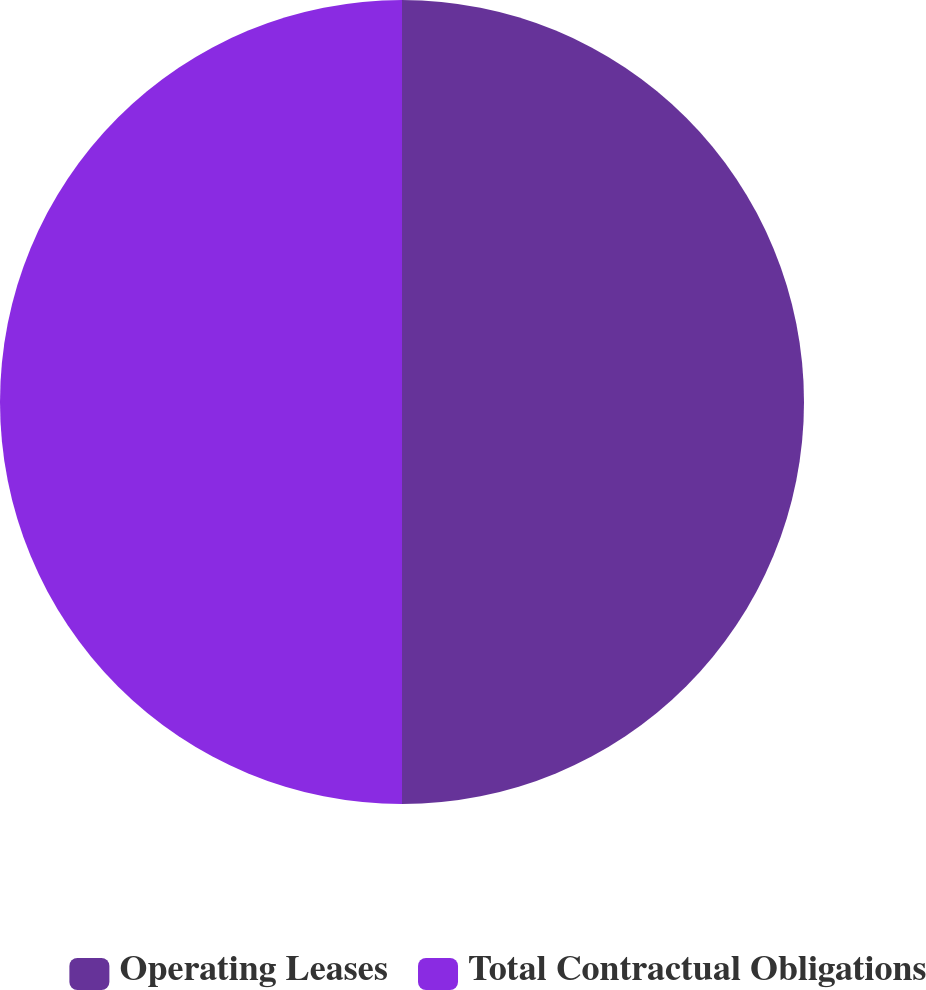Convert chart. <chart><loc_0><loc_0><loc_500><loc_500><pie_chart><fcel>Operating Leases<fcel>Total Contractual Obligations<nl><fcel>50.0%<fcel>50.0%<nl></chart> 